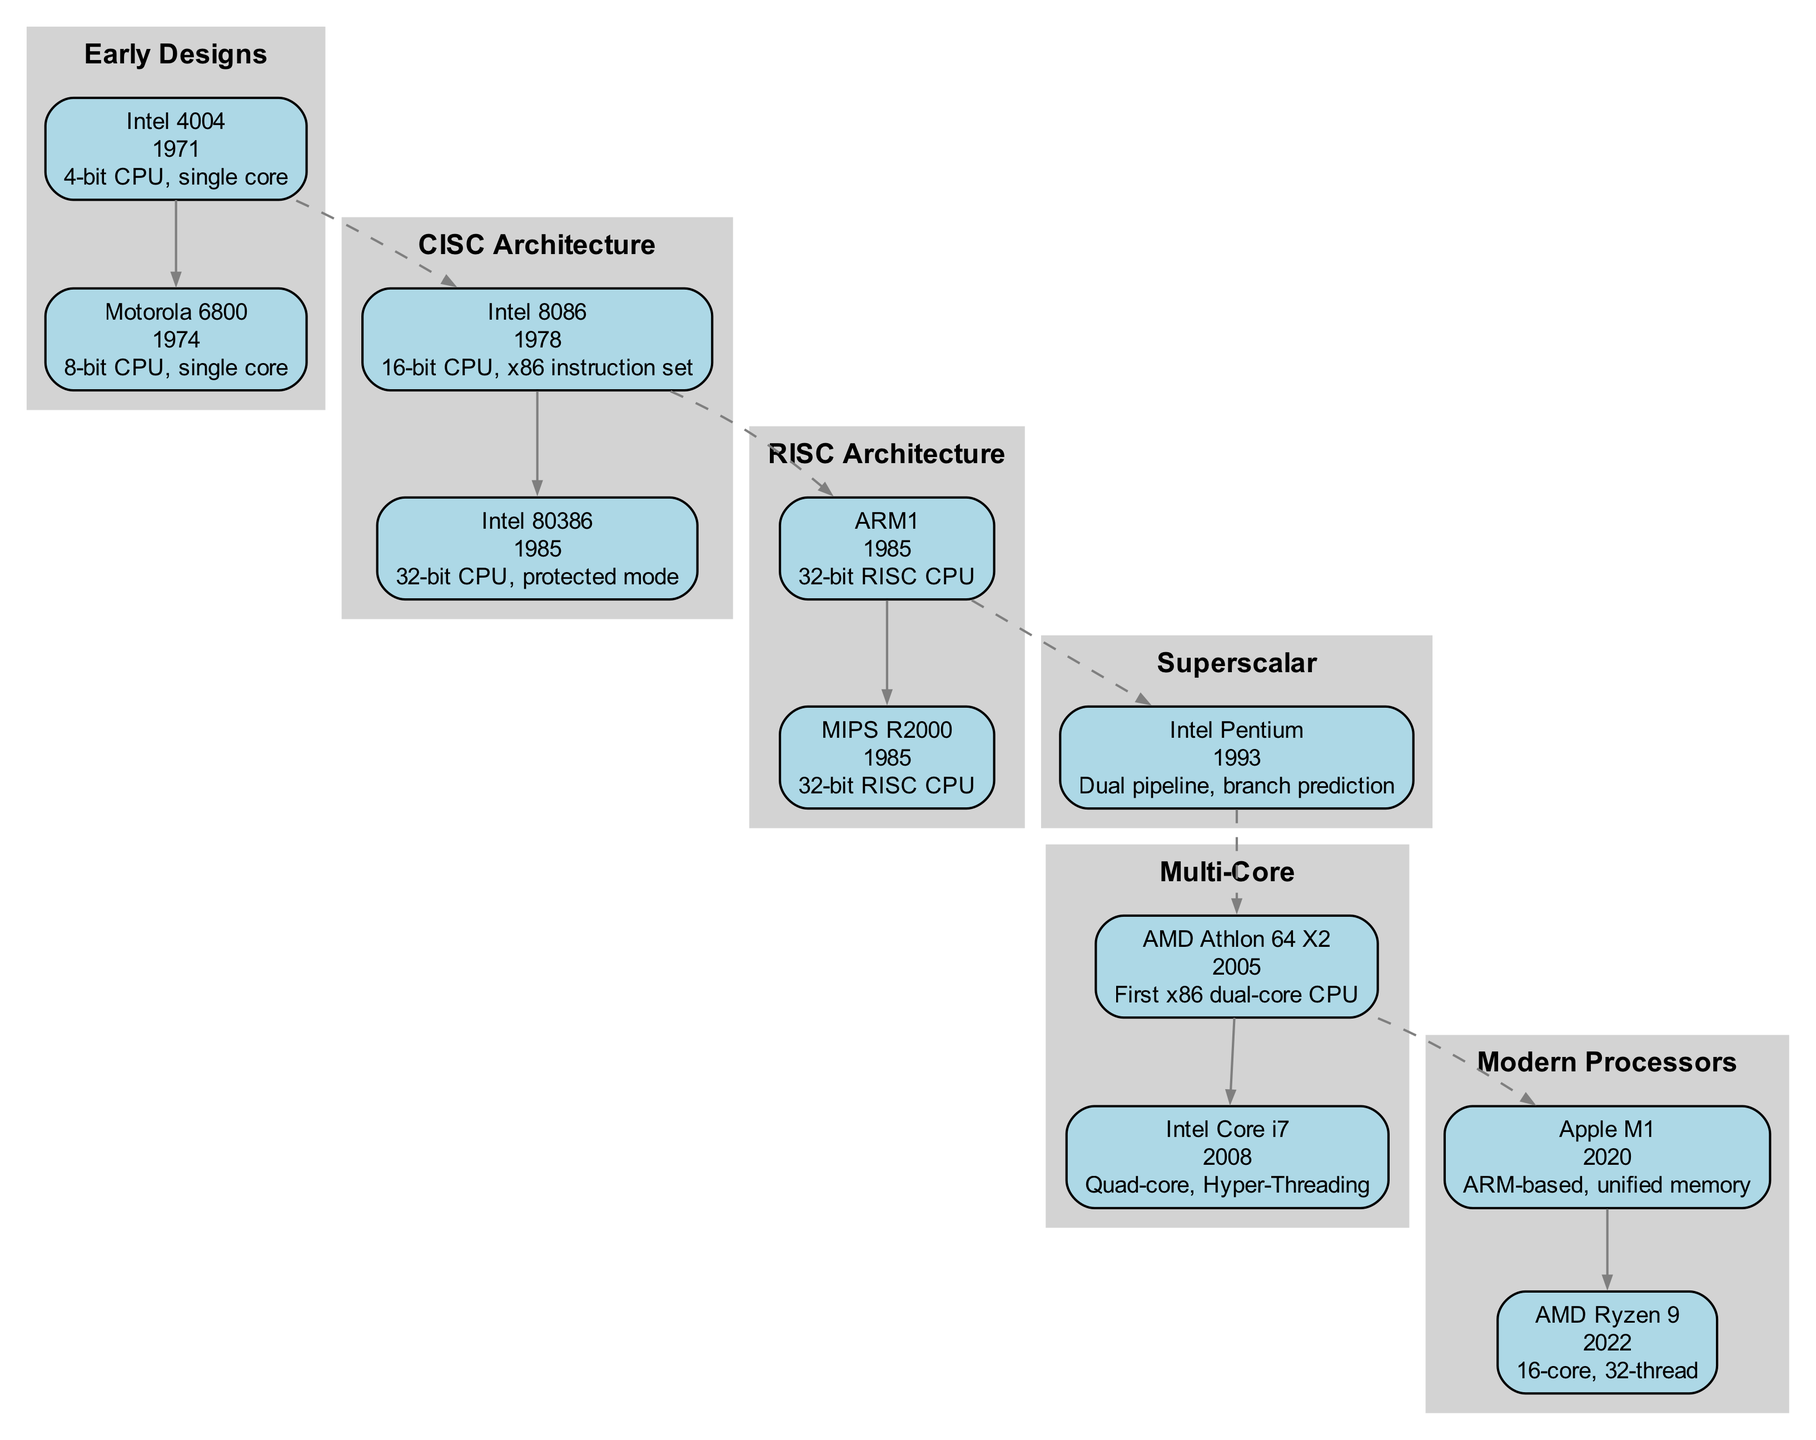What is the first microprocessor in the family tree? The first microprocessor in the family tree is identified under the "Early Designs" category. The Intel 4004, introduced in 1971, is the earliest entry.
Answer: Intel 4004 How many microprocessors are there in the "Multi-Core" category? By counting the nodes listed under the "Multi-Core" section, there are two microprocessors: AMD Athlon 64 X2 and Intel Core i7.
Answer: 2 Which architecture introduced the first 32-bit CPU? The first 32-bit CPU was introduced in the "CISC Architecture" category with the Intel 80386 in 1985.
Answer: Intel 80386 What year was the first ARM-based processor released? Referring to the "Modern Processors" category, the Apple M1, which is ARM-based, was released in 2020.
Answer: 2020 Which processor features branch prediction? The Intel Pentium, categorized under "Superscalar," is known for its dual pipeline architecture and introduction of branch prediction features in 1993.
Answer: Intel Pentium How are the "CISC Architecture" and "RISC Architecture" categories related in terms of year? By examining both categories, both Intel 80386 from CISC and ARM1 from RISC were released in 1985, indicating they are contemporaneous developments.
Answer: 1985 What is the highest core count processor represented in the diagram? The AMD Ryzen 9, introduced in 2022, has the highest core count of 16 cores. This is listed under the "Modern Processors" category.
Answer: AMD Ryzen 9 Which processor is recognized as the first x86 dual-core CPU? The AMD Athlon 64 X2, marked under the "Multi-Core" architecture, is referenced as the first x86 dual-core CPU released in 2005.
Answer: AMD Athlon 64 X2 How many edges connect the "Early Designs" category to "CISC Architecture"? There is one dashed edge that connects the first processor under "Early Designs," the Intel 4004, to the first processor in the "CISC Architecture," the Intel 8086.
Answer: 1 